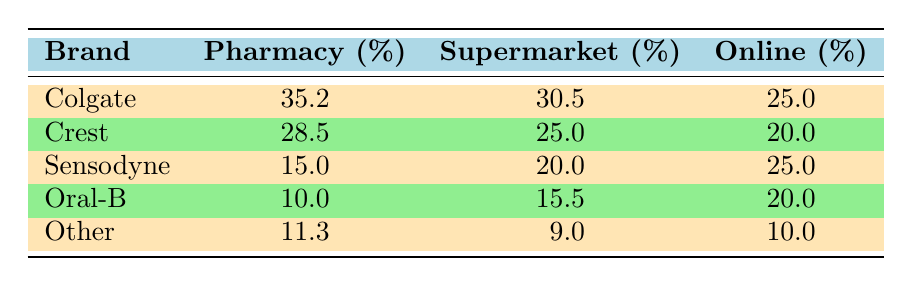What is the market share percentage of Colgate in pharmacies? According to the table, Colgate's market share percentage in pharmacies is listed directly in the Pharmacy column. It states 35.2%.
Answer: 35.2% Which oral care brand has the highest market share in supermarkets? By examining the Supermarket column, Colgate shows the highest market share at 30.5%, compared to the other brands listed.
Answer: Colgate What is the combined market share percentage of Crest in both pharmacy and supermarket channels? First, find Crest's values in both the Pharmacy (28.5%) and Supermarket (25.0%) columns. Next, add them together: 28.5 + 25.0 = 53.5%.
Answer: 53.5% Is Sensodyne's market share higher online or in pharmacies? Sensodyne's online market share is 25.0% while its pharmacy share is 15.0%. Since 25.0% is greater than 15.0%, Sensodyne has a higher market share online.
Answer: Yes What is the average market share percentage of Oral-B across all retail channels? To find the average, add all the percentages for Oral-B: 10.0 (Pharmacy) + 15.5 (Supermarket) + 20.0 (Online) = 45.5. Then divide by the number of channels (3): 45.5 / 3 = 15.17%.
Answer: 15.17% How much less market share percentage does 'Other' have in the supermarket compared to the pharmacy? The market share for 'Other' in the supermarket is 9.0% and in the pharmacy it's 11.3%. Subtract the supermarket percentage from the pharmacy percentage: 11.3 - 9.0 = 2.3%.
Answer: 2.3% Which brand has the lowest market share percentage in pharmacies? Review the Pharmacy column, where Oral-B has the lowest market share at 10.0% compared to Colgate, Crest, and Sensodyne.
Answer: Oral-B 